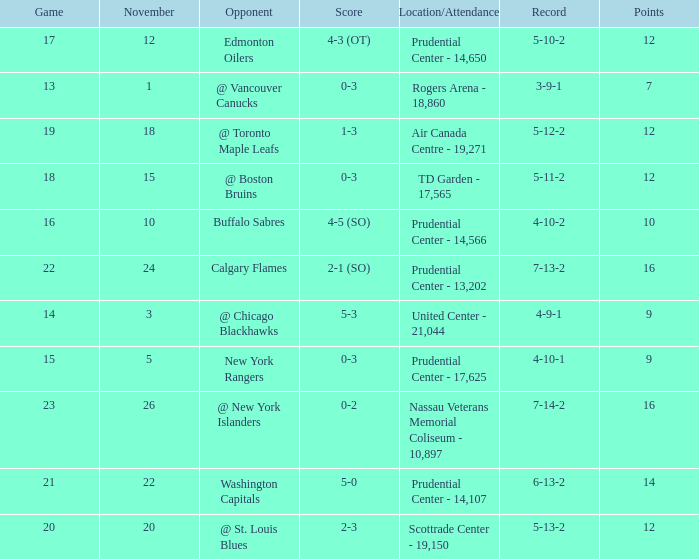What is the total number of locations that had a score of 1-3? 1.0. 